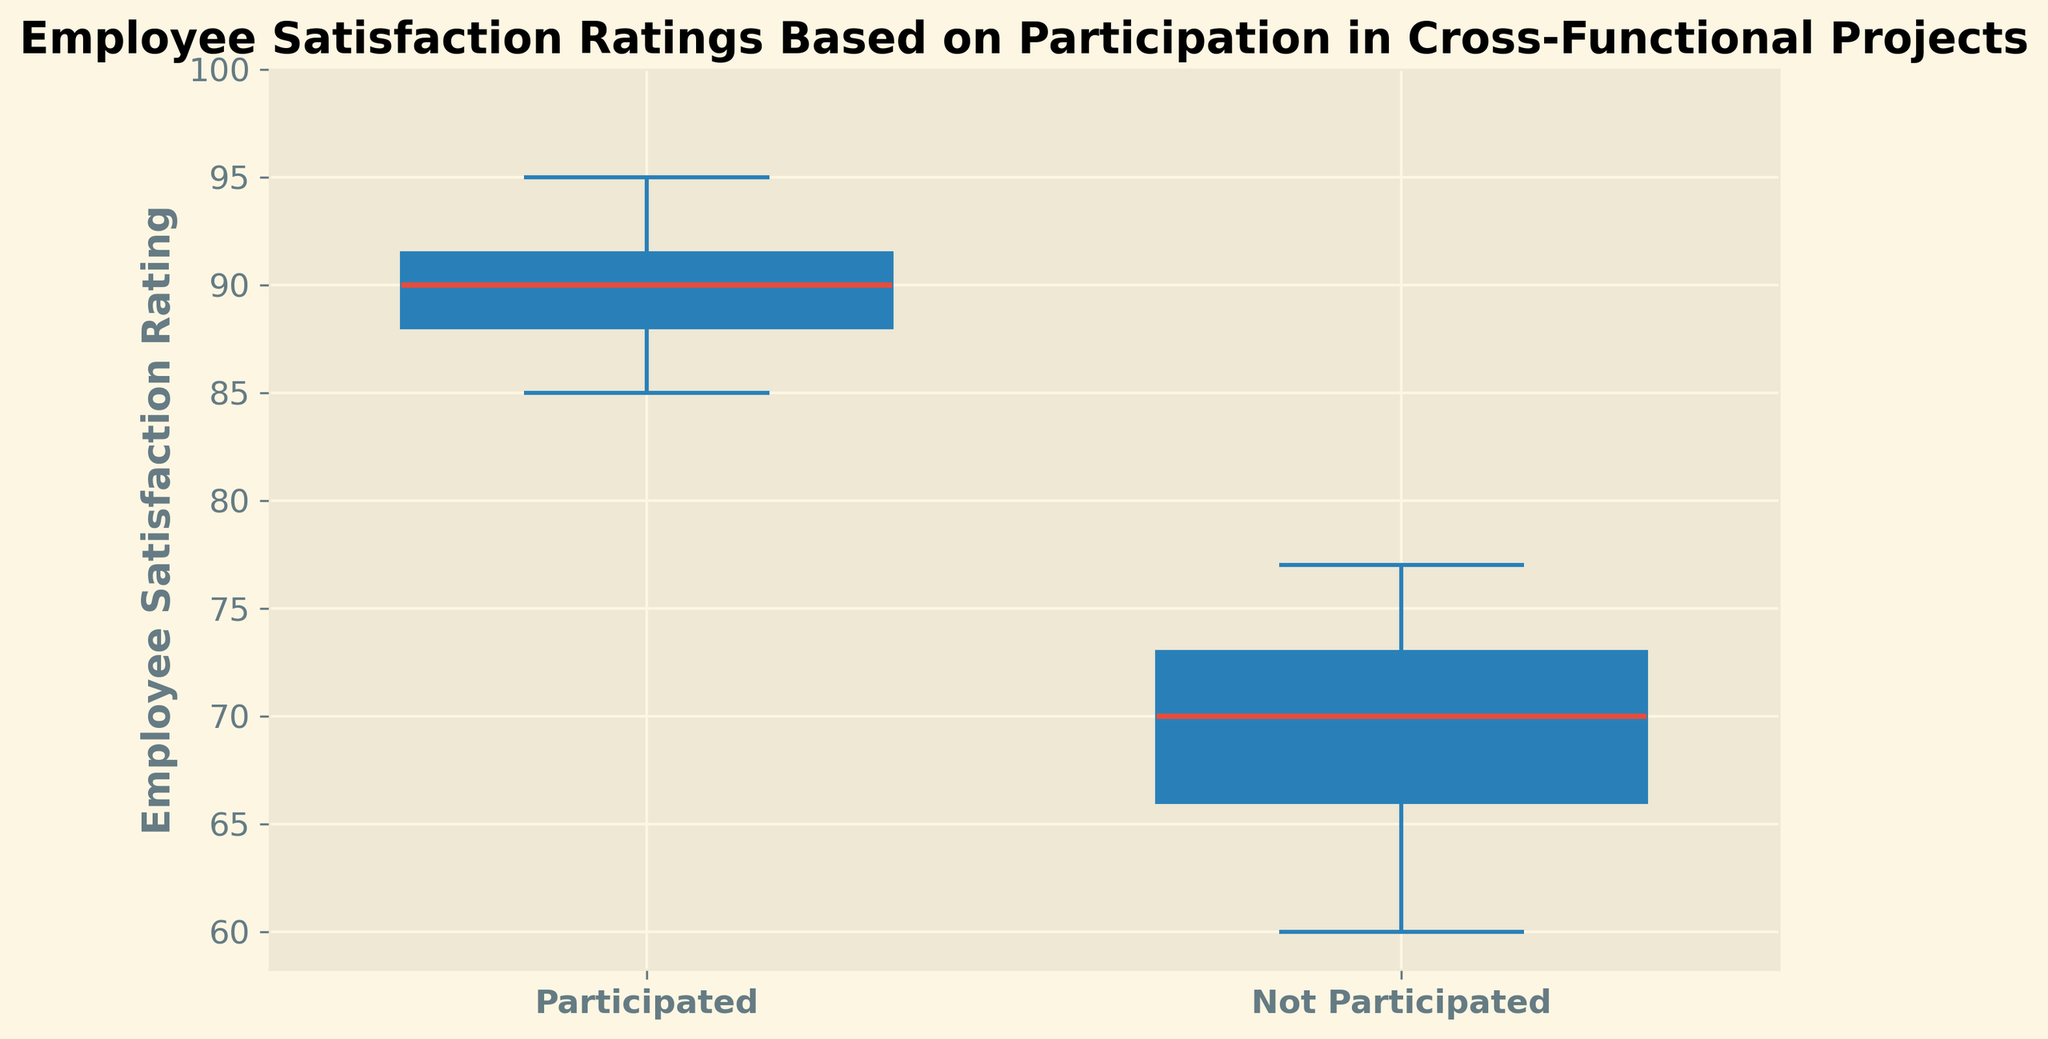Which group has a higher median satisfaction rating, those who participated or those who did not? The box plot shows the median as a horizontal line inside each box. The median line for the "Participated" group is higher than that for the "Not Participated" group.
Answer: Participated What is the median satisfaction rating for employees who participated in cross-functional projects? The median is the horizontal line inside the box for the "Participated" group. Observing the plot, the median for the "Participated" group is 89.
Answer: 89 Which group has a lower range of satisfaction ratings, participated or not participated? The range is the difference between the highest and lowest values shown by the whiskers. The range for the "Participated" group is between 85 and 95, which is smaller compared to the "Not Participated" group, ranging between 60 and 77.
Answer: Participated How much higher is the upper quartile for the participated group compared to the not participated group? The upper quartile is the top edge of the box. The upper quartile for the "Participated" group is around 92, while for the "Not Participated" group, it is around 75. The difference is 92 - 75 = 17.
Answer: 17 Which group shows more spread-out satisfaction ratings, participated or not participated? The spread is indicated by the length of the box and the whiskers. The "Not Participated" group shows a more spread-out range from 60 to 77 compared to the "Participated" group, which ranges from 85 to 95.
Answer: Not Participated What is the interquartile range (IQR) for employees who did not participate in cross-functional projects? The IQR is the range between the first quartile and the third quartile. From the plot, the IQR for the "Not Participated" group is from about 65 to 74. Thus, the IQR is 74 - 65 = 9.
Answer: 9 What is the median difference in satisfaction ratings between the participated and not participated employees? The median for participated employees is 89, and for not participated is around 69. So, the median difference is 89 - 69 = 20.
Answer: 20 Which group has more outliers in its satisfaction ratings, if any? Outliers are indicated by separate dots outside the whiskers. Observing the plot, neither group shows any outliers.
Answer: Neither What is the lowest satisfaction rating reported among employees who did not participate in cross-functional projects? The lowest satisfaction rating is indicated by the bottom whisker of the "Not Participated" group, which is around 60.
Answer: 60 